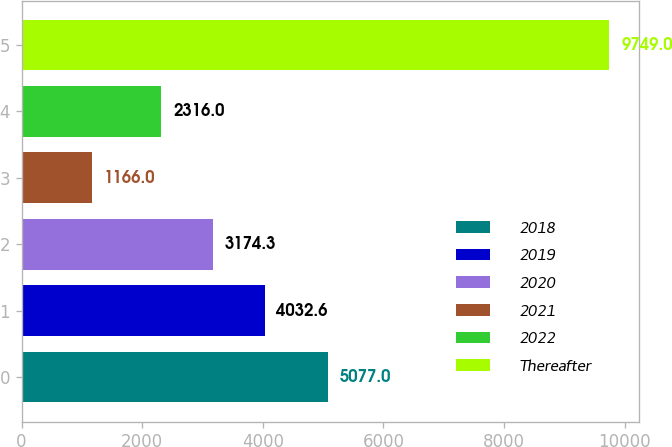Convert chart to OTSL. <chart><loc_0><loc_0><loc_500><loc_500><bar_chart><fcel>2018<fcel>2019<fcel>2020<fcel>2021<fcel>2022<fcel>Thereafter<nl><fcel>5077<fcel>4032.6<fcel>3174.3<fcel>1166<fcel>2316<fcel>9749<nl></chart> 